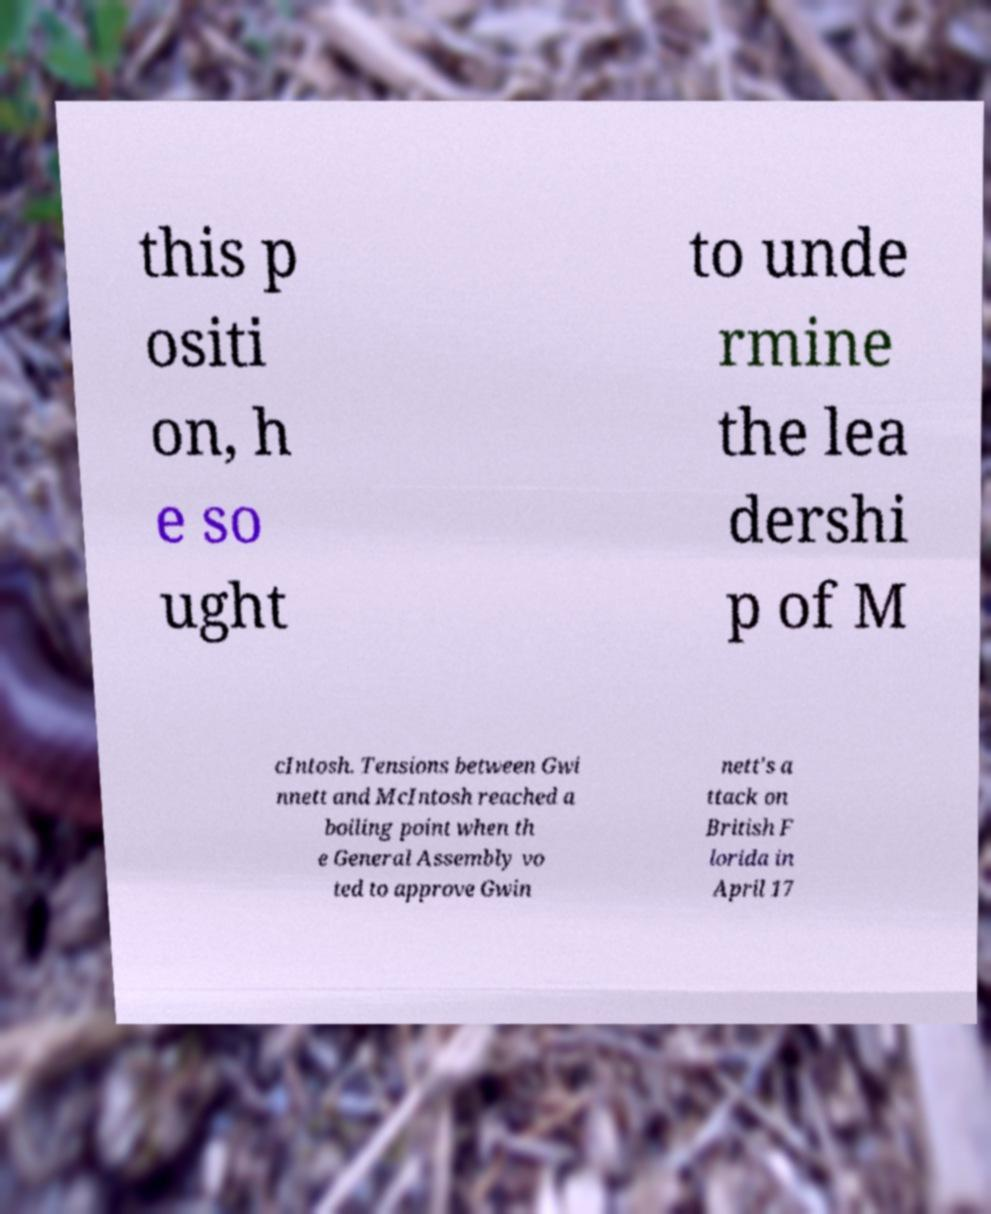Could you extract and type out the text from this image? this p ositi on, h e so ught to unde rmine the lea dershi p of M cIntosh. Tensions between Gwi nnett and McIntosh reached a boiling point when th e General Assembly vo ted to approve Gwin nett's a ttack on British F lorida in April 17 